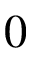<formula> <loc_0><loc_0><loc_500><loc_500>0</formula> 